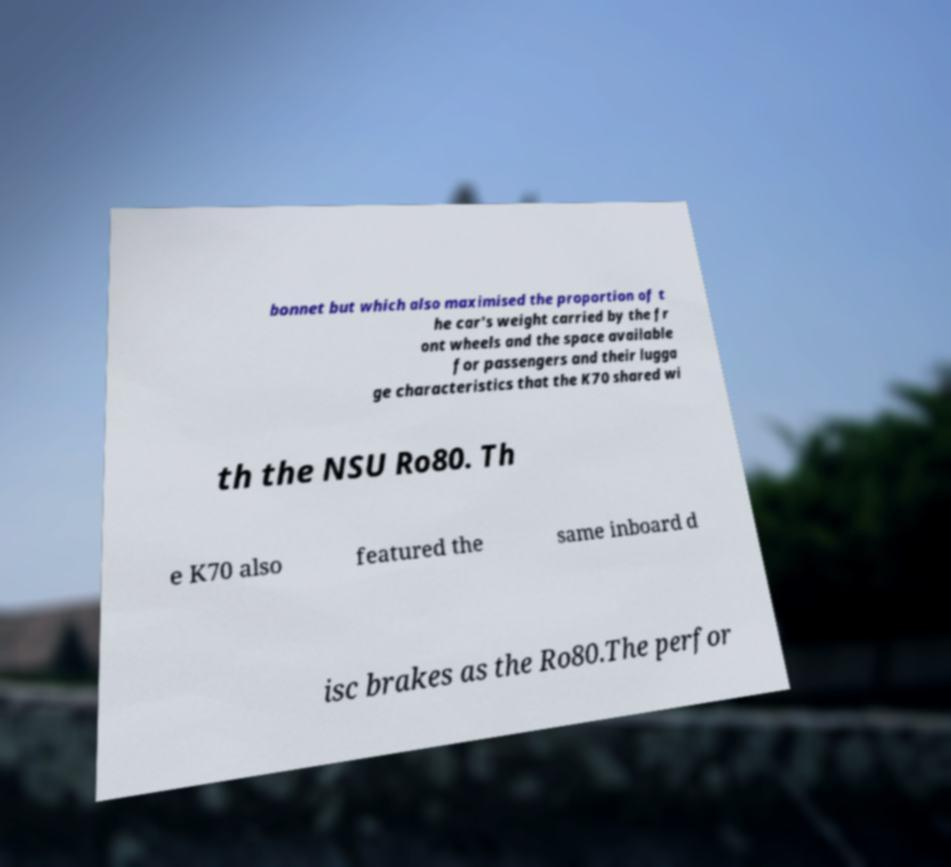For documentation purposes, I need the text within this image transcribed. Could you provide that? bonnet but which also maximised the proportion of t he car's weight carried by the fr ont wheels and the space available for passengers and their lugga ge characteristics that the K70 shared wi th the NSU Ro80. Th e K70 also featured the same inboard d isc brakes as the Ro80.The perfor 